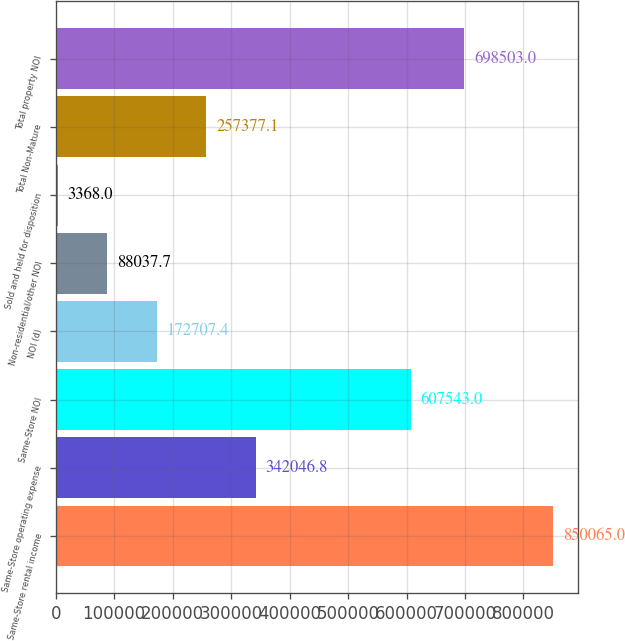<chart> <loc_0><loc_0><loc_500><loc_500><bar_chart><fcel>Same-Store rental income<fcel>Same-Store operating expense<fcel>Same-Store NOI<fcel>NOI (d)<fcel>Non-residential/other NOI<fcel>Sold and held for disposition<fcel>Total Non-Mature<fcel>Total property NOI<nl><fcel>850065<fcel>342047<fcel>607543<fcel>172707<fcel>88037.7<fcel>3368<fcel>257377<fcel>698503<nl></chart> 